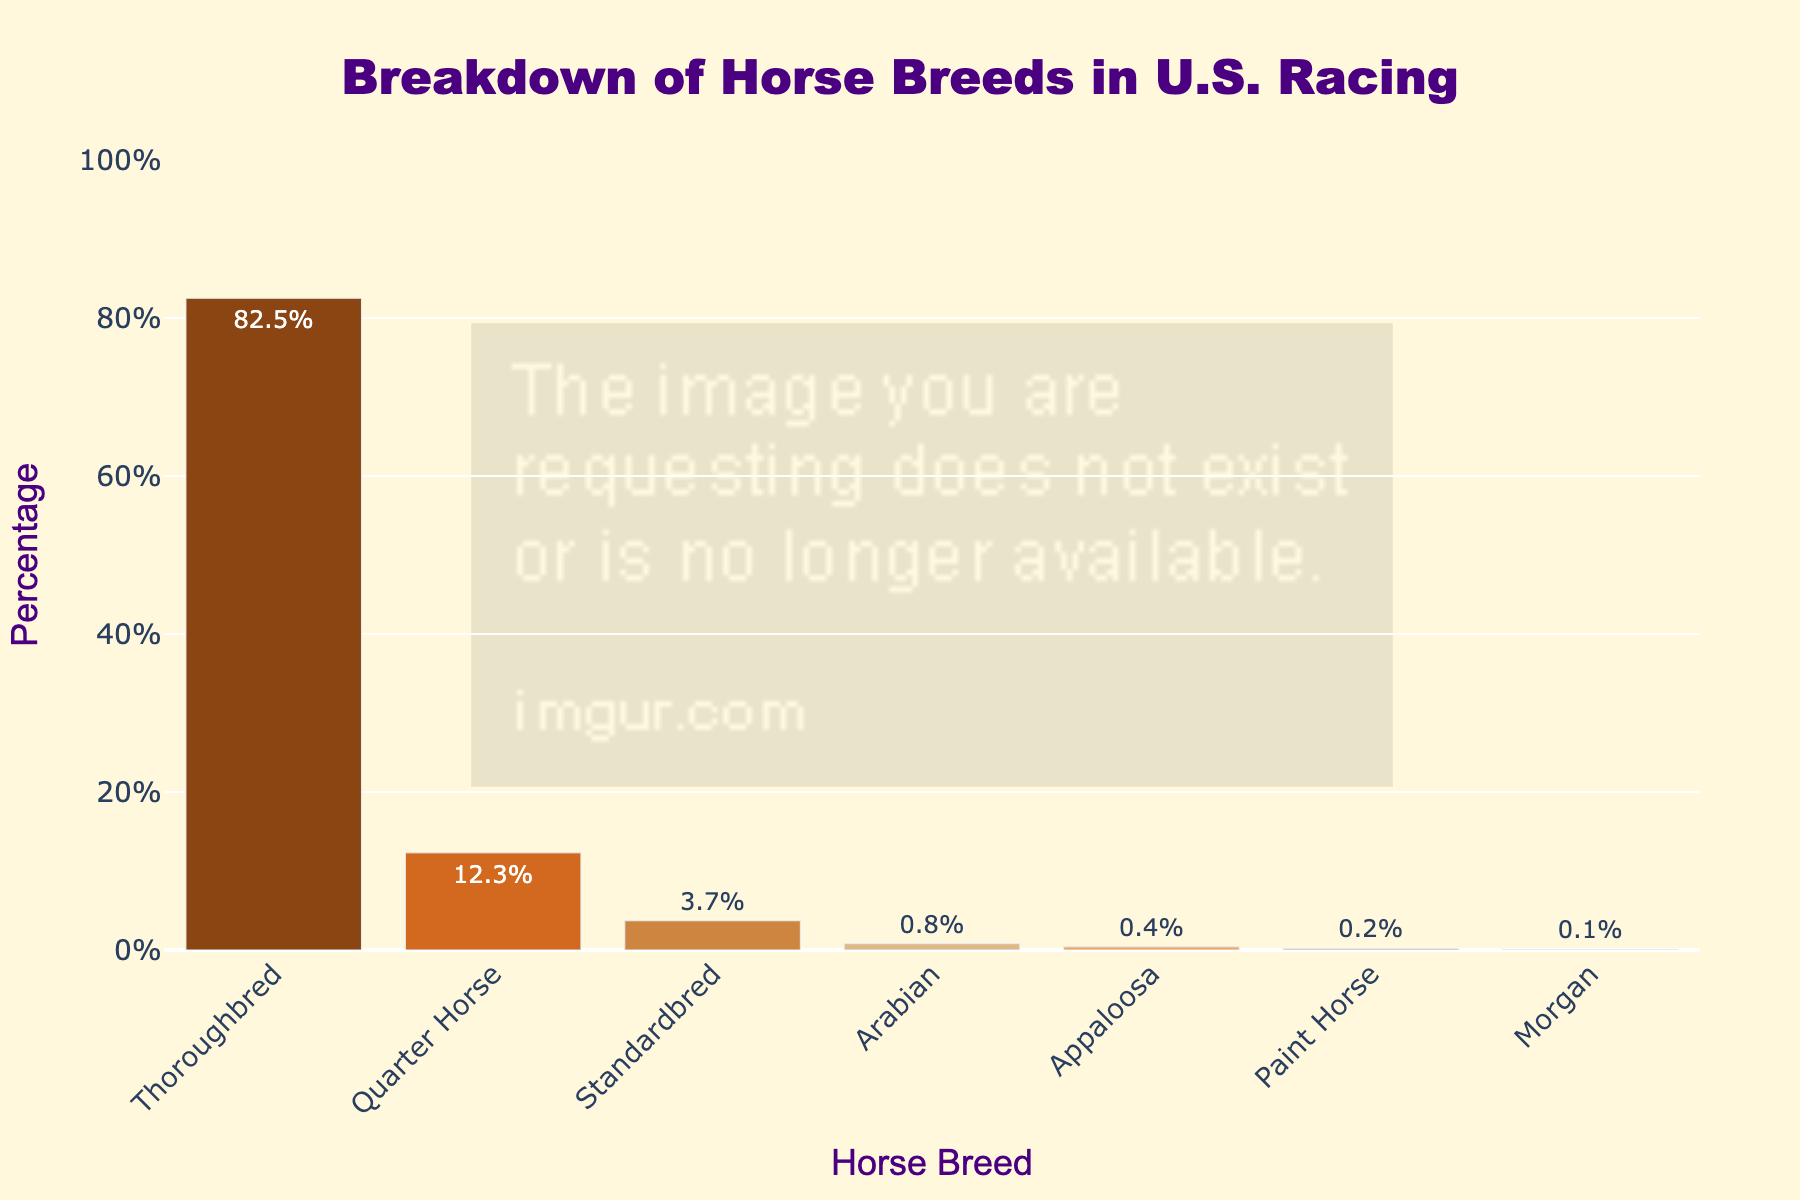Which horse breed has the highest percentage in U.S. racing? The figure shows a bar chart with the percentages of different horse breeds. The breed with the tallest bar represents the highest percentage. The Thoroughbred breed has the highest bar.
Answer: Thoroughbred What's the combined percentage of Quarter Horse and Standardbred in U.S. racing? To find the combined percentage, add the percentages of the Quarter Horse (12.3%) and Standardbred (3.7%). 12.3% + 3.7% = 16%.
Answer: 16% Which horse breeds have less than 1% participation in U.S. racing? The figure shows the percentage below each bar. The breeds with less than 1% are those with bars representing percentages less than 1%. The breeds are Arabian (0.8%), Appaloosa (0.4%), Paint Horse (0.2%), and Morgan (0.1%).
Answer: Arabian, Appaloosa, Paint Horse, Morgan What is the percentage difference between Thoroughbred and Standardbred breeds? To find the difference, subtract the percentage of Standardbred (3.7%) from that of Thoroughbred (82.5%). 82.5% - 3.7% = 78.8%.
Answer: 78.8% How does the height of the bar representing Paint Horse compare to the height of the bar representing Morgan? Visually compare the heights of the bars for Paint Horse and Morgan. The Paint Horse bar is twice as high compared to the Morgan bar since the percentage is 0.2% for Paint Horse and 0.1% for Morgan.
Answer: Paint Horse is twice as high as Morgan Which horse breed has the second highest percentage in U.S. racing, and what is its percentage? Identify the horse breed with the second tallest bar. The second tallest bar is for Quarter Horse with the percentage shown as 12.3%.
Answer: Quarter Horse, 12.3% What's the average percentage of the horse breeds with participation over 3%? Determine the breeds with percentages over 3% (Thoroughbred: 82.5%, Quarter Horse: 12.3%, Standardbred: 3.7%). Sum these percentages (82.5 + 12.3 + 3.7 = 98.5) and divide by 3. The average percentage is 98.5 / 3 = 32.83%.
Answer: 32.83% How many breeds are represented in the figure? Count the number of unique breeds listed on the x-axis of the bar chart. There are seven breeds listed (Thoroughbred, Quarter Horse, Standardbred, Arabian, Appaloosa, Paint Horse, Morgan).
Answer: 7 